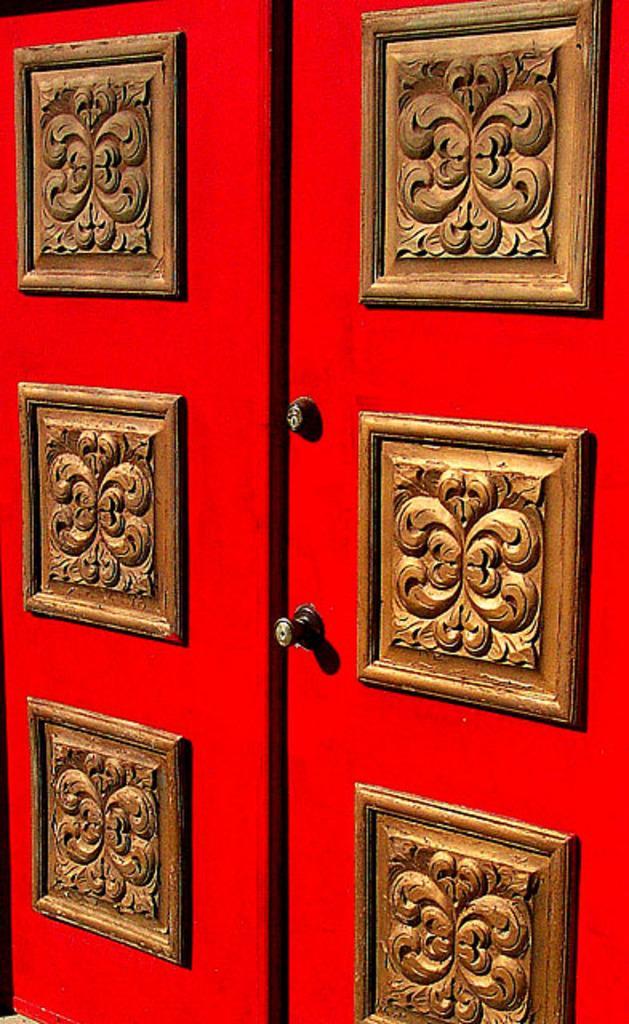In one or two sentences, can you explain what this image depicts? In this image, we can see red color doors with wooden sculpture on it. 